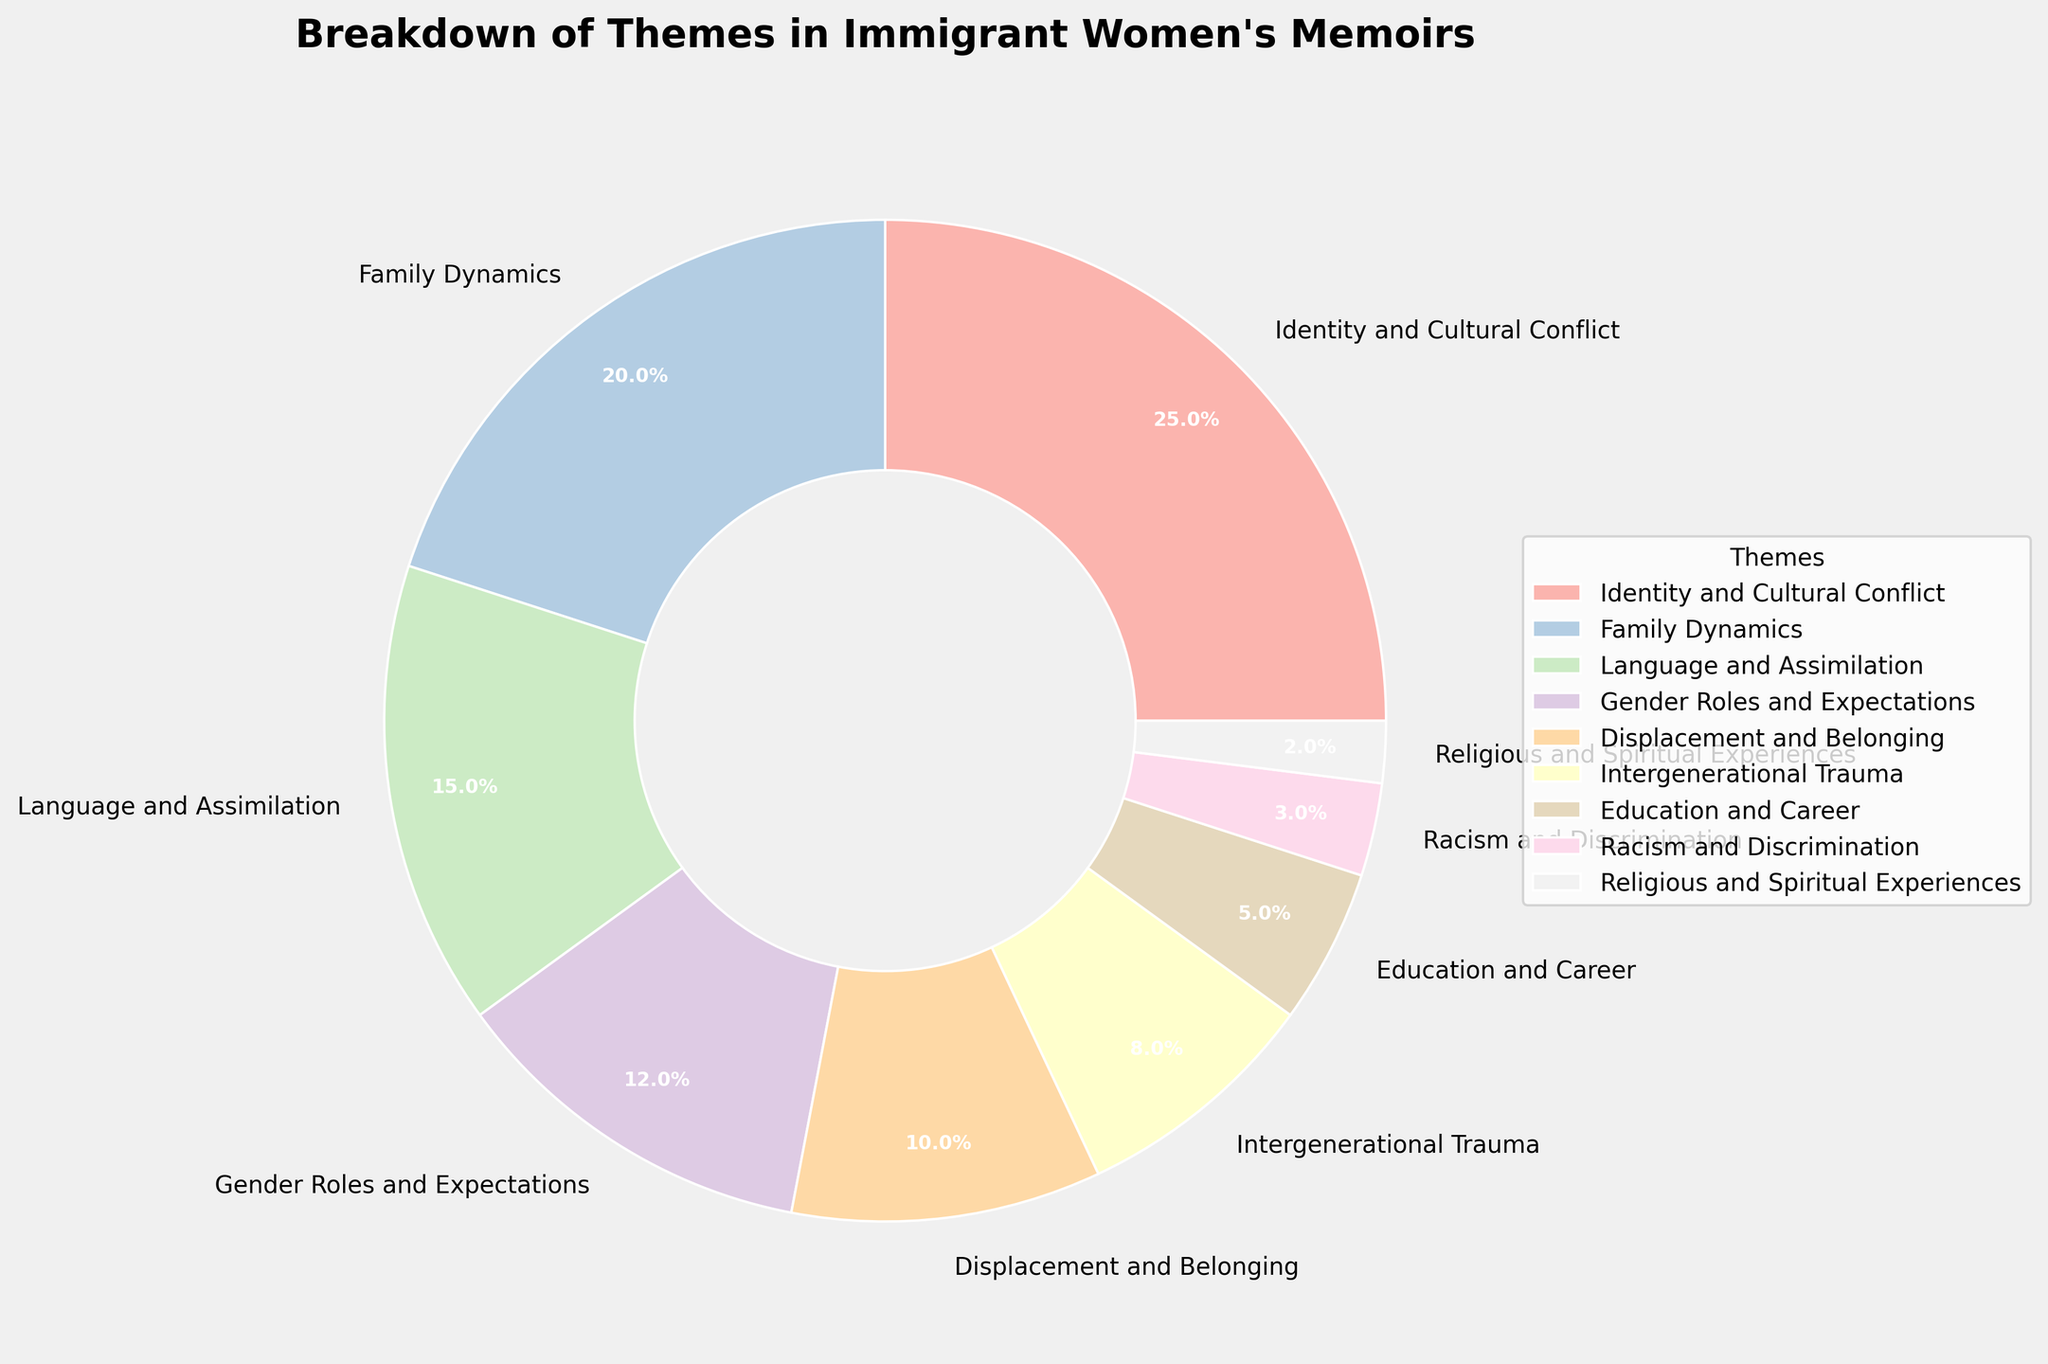Which theme occupies the largest portion of the pie chart? The theme "Identity and Cultural Conflict" is shown taking up the largest segment of the pie chart at 25%.
Answer: Identity and Cultural Conflict What is the combined percentage of themes related to Family Dynamics, Language and Assimilation, and Gender Roles and Expectations? Sum the percentages of the themes: 20% (Family Dynamics) + 15% (Language and Assimilation) + 12% (Gender Roles and Expectations) = 47%.
Answer: 47% How does the percentage of Displacement and Belonging compare to that of Education and Career? The percentage of Displacement and Belonging is 10%, which is twice the percentage of Education and Career at 5%.
Answer: Displacement and Belonging is twice as much as Education and Career Which theme is shown as the smallest segment, and what percentage does it represent? The smallest segment of the pie chart represents "Religious and Spiritual Experiences" at 2%.
Answer: Religious and Spiritual Experiences, 2% What is the difference in percentage between the themes Gender Roles and Expectations and Racism and Discrimination? Subtract the percentage of Racism and Discrimination from that of Gender Roles and Expectations: 12% - 3% = 9%.
Answer: 9% How do the visual sizes of Identity and Cultural Conflict and Family Dynamics segments compare? The segment for "Identity and Cultural Conflict" is shown to be larger than the "Family Dynamics" segment in the pie chart.
Answer: Identity and Cultural Conflict is larger than Family Dynamics What is the total percentage of themes that have less than 10% representation each? Add the percentages of themes with less than 10% representation: Intergenerational Trauma (8%), Education and Career (5%), Racism and Discrimination (3%), and Religious and Spiritual Experiences (2%) - 8% + 5% + 3% + 2% = 18%.
Answer: 18% Which themes have equal or nearly equal proportions within the pie chart? The themes "Displacement and Belonging" (10%) and "Intergenerational Trauma" (8%) are the closest in their proportions.
Answer: Displacement and Belonging and Intergenerational Trauma How do the themes related to identity (Identity and Cultural Conflict + Language and Assimilation) compare to those related to familial aspects (Family Dynamics + Intergenerational Trauma)? Sum the percentages for identity-related themes: 25% (Identity and Cultural Conflict) + 15% (Language and Assimilation) = 40%. Sum the percentages for familial aspects: 20% (Family Dynamics) + 8% (Intergenerational Trauma) = 28%. Identity-related themes (40%) have a higher total percentage compared to familial aspects (28%).
Answer: Identity-related themes (40%) are greater than familial aspects (28%) What's the percentage difference between the highest and the lowest themes? Subtract the lowest percentage (Religious and Spiritual Experiences, 2%) from the highest percentage (Identity and Cultural Conflict, 25%): 25% - 2% = 23%.
Answer: 23% 